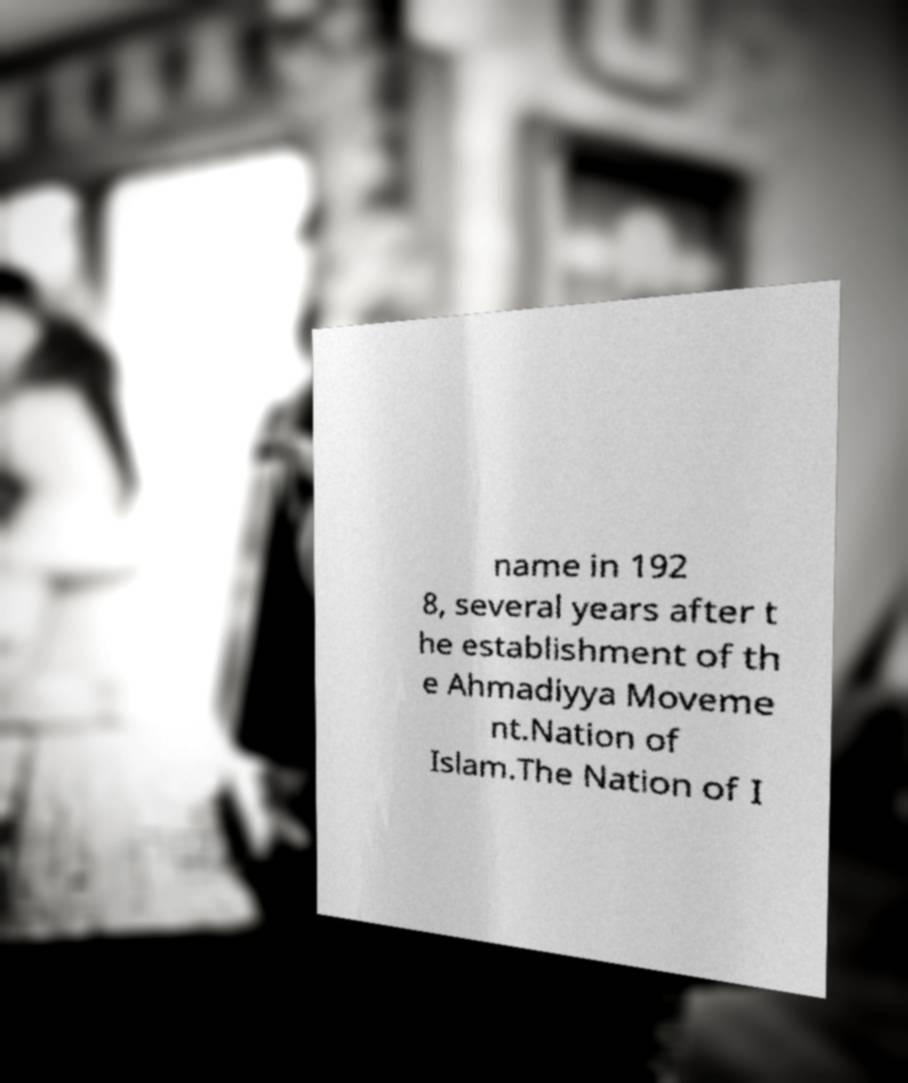There's text embedded in this image that I need extracted. Can you transcribe it verbatim? name in 192 8, several years after t he establishment of th e Ahmadiyya Moveme nt.Nation of Islam.The Nation of I 